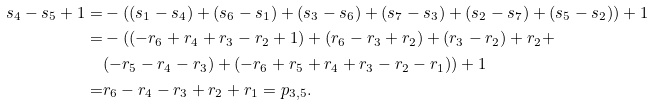<formula> <loc_0><loc_0><loc_500><loc_500>s _ { 4 } - s _ { 5 } + 1 = & - ( ( s _ { 1 } - s _ { 4 } ) + ( s _ { 6 } - s _ { 1 } ) + ( s _ { 3 } - s _ { 6 } ) + ( s _ { 7 } - s _ { 3 } ) + ( s _ { 2 } - s _ { 7 } ) + ( s _ { 5 } - s _ { 2 } ) ) + 1 \\ = & - ( ( - r _ { 6 } + r _ { 4 } + r _ { 3 } - r _ { 2 } + 1 ) + ( r _ { 6 } - r _ { 3 } + r _ { 2 } ) + ( r _ { 3 } - r _ { 2 } ) + r _ { 2 } + \\ & ( - r _ { 5 } - r _ { 4 } - r _ { 3 } ) + ( - r _ { 6 } + r _ { 5 } + r _ { 4 } + r _ { 3 } - r _ { 2 } - r _ { 1 } ) ) + 1 \\ = & r _ { 6 } - r _ { 4 } - r _ { 3 } + r _ { 2 } + r _ { 1 } = p _ { 3 , 5 } .</formula> 